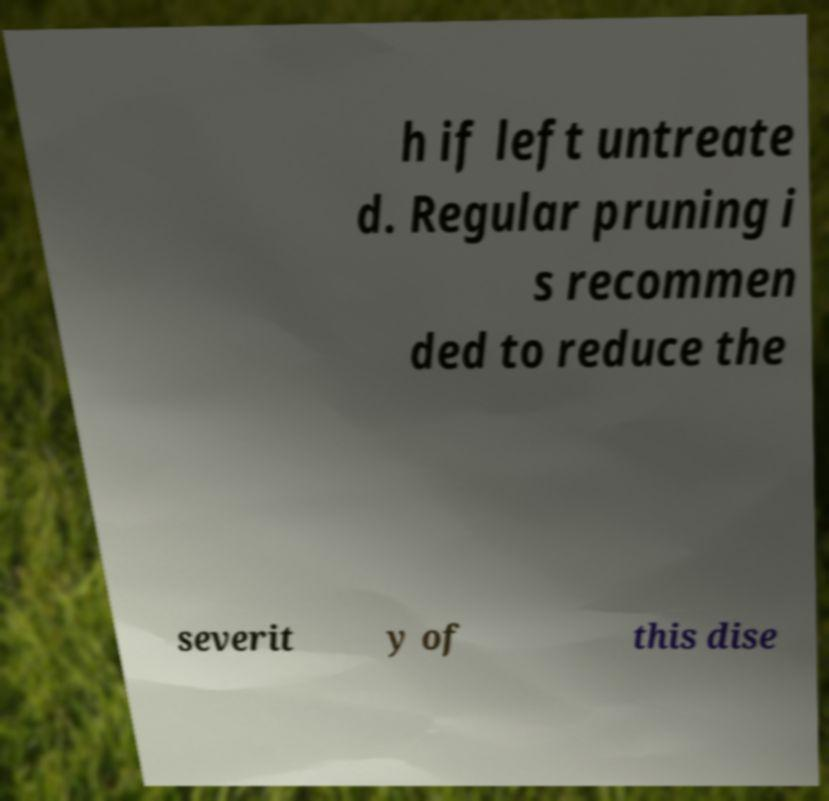Can you read and provide the text displayed in the image?This photo seems to have some interesting text. Can you extract and type it out for me? h if left untreate d. Regular pruning i s recommen ded to reduce the severit y of this dise 